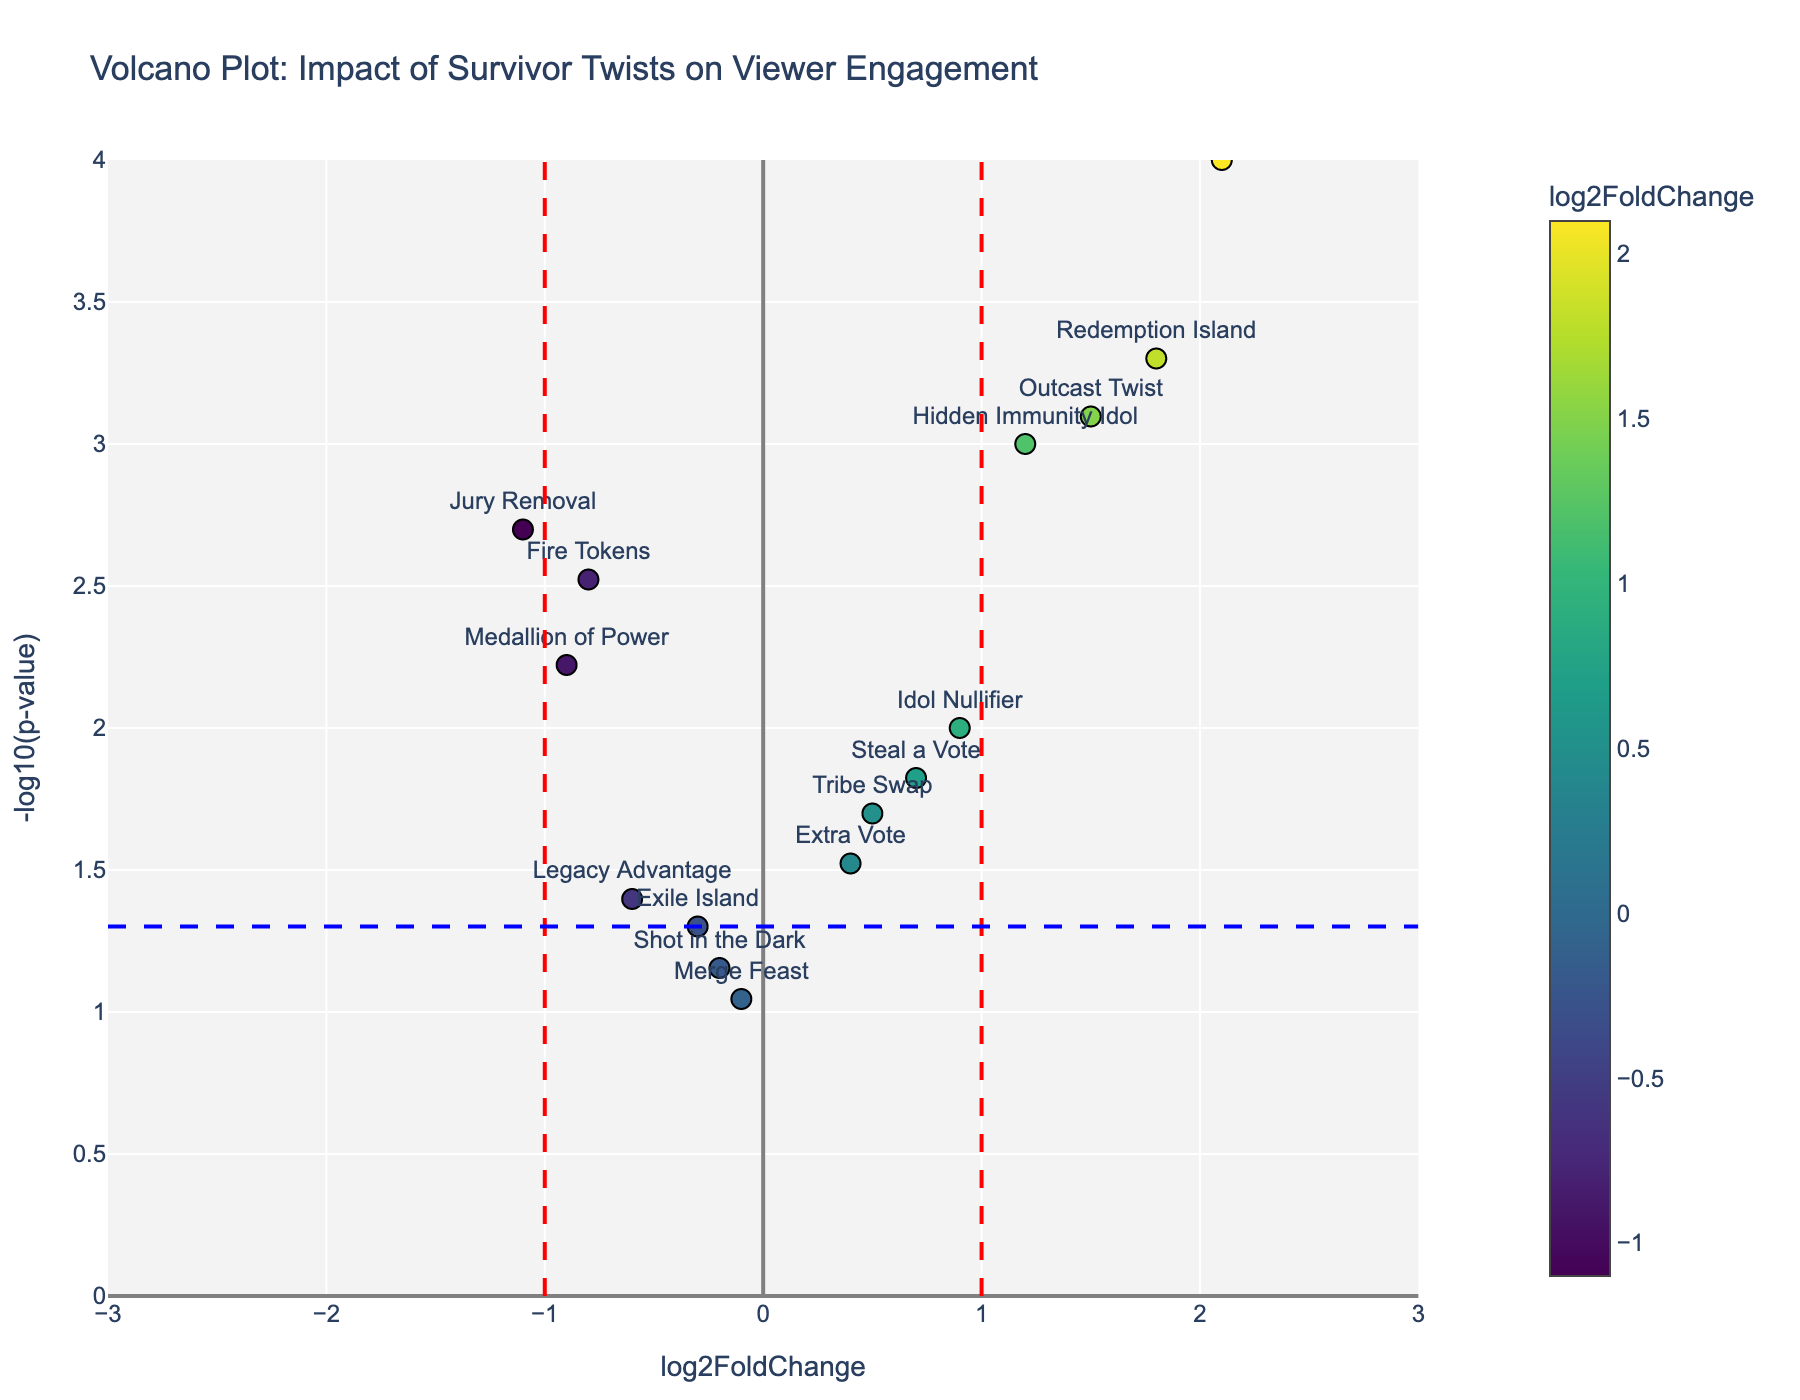What is the title of the plot? The title is displayed at the top of the plot. It reads "Volcano Plot: Impact of Survivor Twists on Viewer Engagement".
Answer: Volcano Plot: Impact of Survivor Twists on Viewer Engagement How many twists have a log2FoldChange greater than 1? Identify the data points (twists) on the plot with a log2FoldChange value greater than 1. There are four twists: Hidden Immunity Idol, Edge of Extinction, Redemption Island, and Outcast Twist.
Answer: Four Which twist has the highest -log10(p-value)? Look for the data point that is highest on the plot, signifying the largest -log10(p-value). This is "Edge of Extinction".
Answer: Edge of Extinction What color represents the highest log2FoldChange values in the plot? The color scale used in the plot indicates higher log2FoldChange values with a specific color. The highest log2FoldChange values are represented in a yellow hue.
Answer: Yellow Which twists have a statistically significant p-value (below 0.05) but have a negative log2FoldChange? Examine the data points below the blue dashed line (-log10(0.05)) and check for those with a negative log2FoldChange. These are "Fire Tokens", "Legacy Advantage", "Medallion of Power", and "Jury Removal".
Answer: Fire Tokens, Legacy Advantage, Medallion of Power, Jury Removal Which twist has the lowest log2FoldChange value and what is its p-value? Find the data point farthest to the left to get the twist with the lowest log2FoldChange value. "Jury Removal" has the lowest log2FoldChange value of -1.1 with a p-value of 0.002.
Answer: Jury Removal with 0.002 How many twists fall outside the threshold lines (log2FoldChange of -1 and 1)? Count the number of points outside the red dashed vertical lines at -1 and 1. There are eight such points: Hidden Immunity Idol, Edge of Extinction, Redemption Island, Outcast Twist, Fire Tokens, Jury Removal, Medallion of Power, and Legacy Advantage.
Answer: Eight Which twist is nearest to the origin (0, 0) of the plot? Identify the data point closest to the (0,0) coordinates. The "Merge Feast" twist is nearest to the origin.
Answer: Merge Feast Comparing "Hidden Immunity Idol" and "Fire Tokens," which has a higher -log10(p-value) and what is that value? Look at the y-axis positions of "Hidden Immunity Idol" and "Fire Tokens." "Hidden Immunity Idol" is higher, with a -log10(p-value) closer to 3.
Answer: Hidden Immunity Idol with approximately 3 